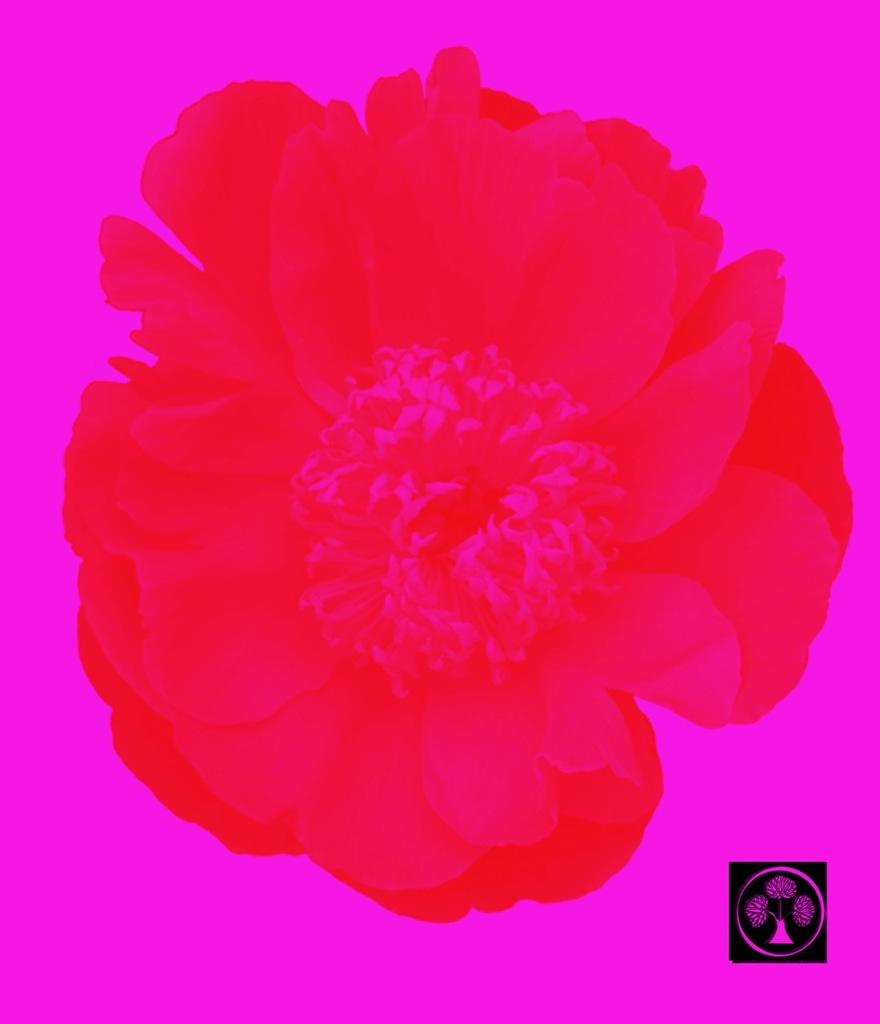What is the main subject of the painting in the image? The painting depicts a flower. What color is the flower in the painting? The flower is red in color. What is the color of the background in the painting? The background of the painting is pink in color. What type of jam is being spread on the tiger in the image? There is no jam or tiger present in the image; it features a painting of a red flower with a pink background. 